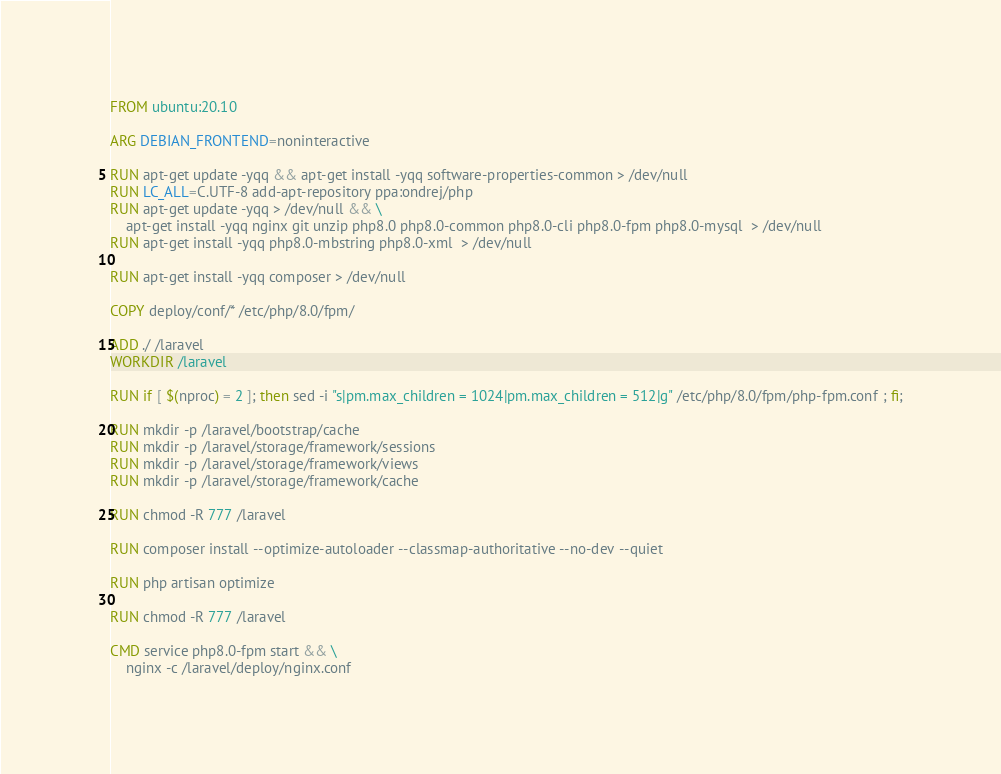<code> <loc_0><loc_0><loc_500><loc_500><_Dockerfile_>FROM ubuntu:20.10

ARG DEBIAN_FRONTEND=noninteractive

RUN apt-get update -yqq && apt-get install -yqq software-properties-common > /dev/null
RUN LC_ALL=C.UTF-8 add-apt-repository ppa:ondrej/php
RUN apt-get update -yqq > /dev/null && \
    apt-get install -yqq nginx git unzip php8.0 php8.0-common php8.0-cli php8.0-fpm php8.0-mysql  > /dev/null
RUN apt-get install -yqq php8.0-mbstring php8.0-xml  > /dev/null

RUN apt-get install -yqq composer > /dev/null

COPY deploy/conf/* /etc/php/8.0/fpm/

ADD ./ /laravel
WORKDIR /laravel

RUN if [ $(nproc) = 2 ]; then sed -i "s|pm.max_children = 1024|pm.max_children = 512|g" /etc/php/8.0/fpm/php-fpm.conf ; fi;

RUN mkdir -p /laravel/bootstrap/cache
RUN mkdir -p /laravel/storage/framework/sessions
RUN mkdir -p /laravel/storage/framework/views
RUN mkdir -p /laravel/storage/framework/cache

RUN chmod -R 777 /laravel

RUN composer install --optimize-autoloader --classmap-authoritative --no-dev --quiet

RUN php artisan optimize

RUN chmod -R 777 /laravel

CMD service php8.0-fpm start && \
    nginx -c /laravel/deploy/nginx.conf
</code> 